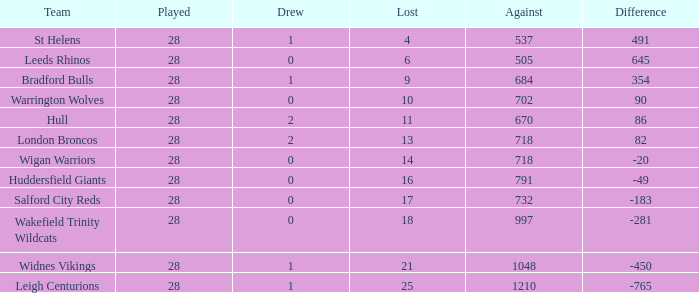What is the most lost games for the team with a difference smaller than 86 and points of 32? None. 